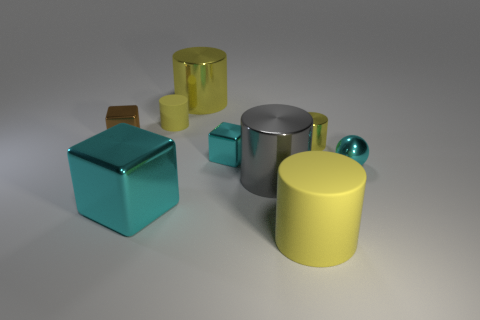Are there more yellow metal things that are behind the small yellow rubber cylinder than matte things in front of the brown cube?
Provide a short and direct response. No. What is the size of the shiny sphere?
Make the answer very short. Small. Do the tiny cylinder that is behind the brown metal cube and the sphere have the same color?
Your answer should be compact. No. There is a small metal block on the right side of the small yellow rubber cylinder; is there a large metal cylinder behind it?
Offer a terse response. Yes. Is the number of gray shiny cylinders behind the small brown metallic thing less than the number of tiny yellow rubber things that are right of the large metal cube?
Keep it short and to the point. Yes. What size is the rubber object behind the metal block that is right of the large shiny cylinder behind the brown cube?
Your answer should be very brief. Small. Is the size of the cyan thing behind the ball the same as the gray cylinder?
Offer a terse response. No. What number of other objects are there of the same material as the gray thing?
Provide a short and direct response. 6. Are there more small shiny spheres than large cyan metallic balls?
Ensure brevity in your answer.  Yes. What is the big yellow cylinder in front of the matte thing to the left of the object that is in front of the big cyan metallic thing made of?
Offer a very short reply. Rubber. 